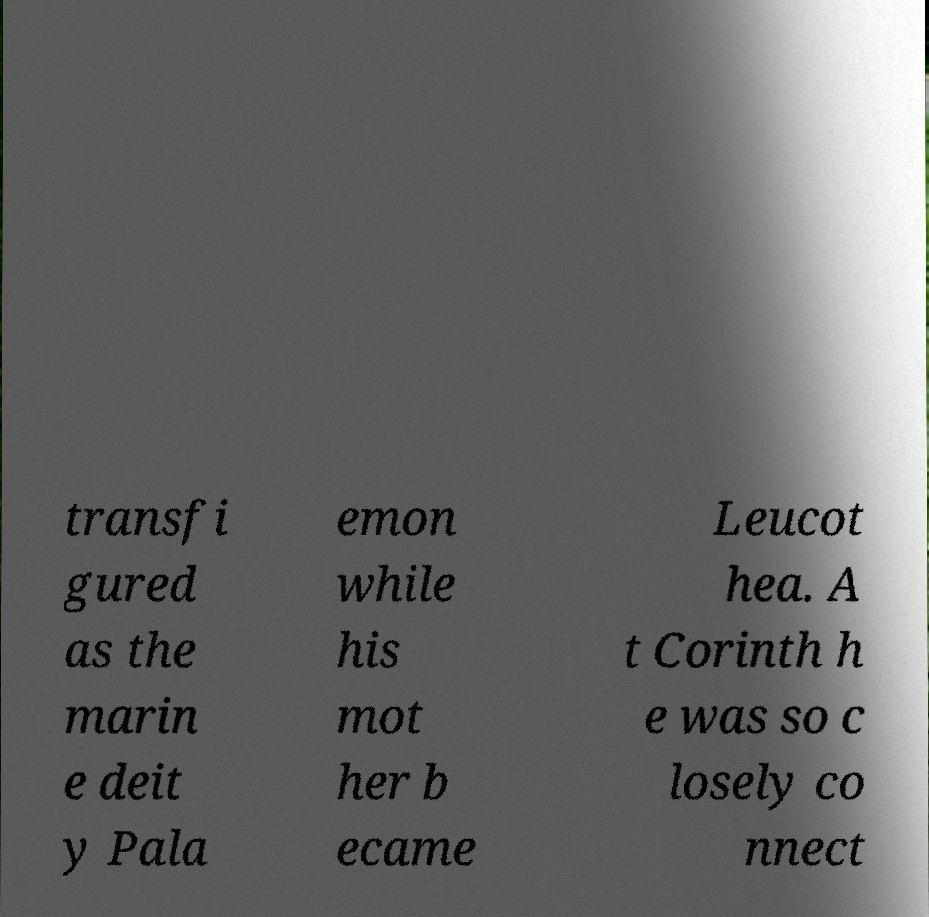Can you read and provide the text displayed in the image?This photo seems to have some interesting text. Can you extract and type it out for me? transfi gured as the marin e deit y Pala emon while his mot her b ecame Leucot hea. A t Corinth h e was so c losely co nnect 